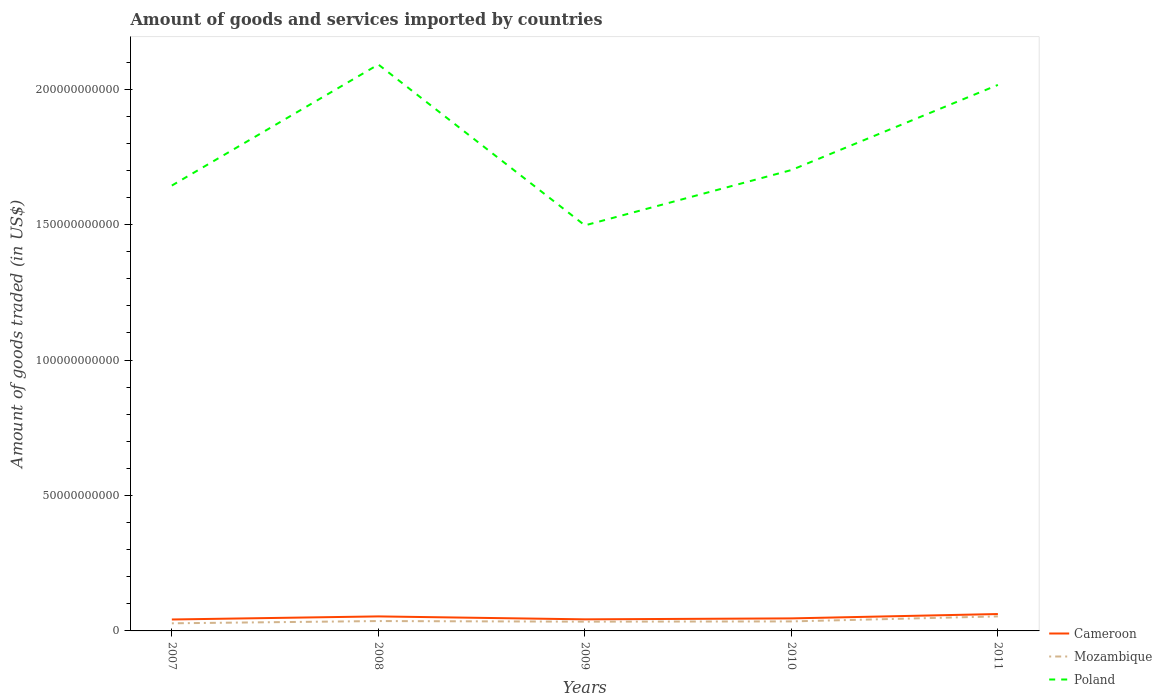How many different coloured lines are there?
Make the answer very short. 3. Does the line corresponding to Poland intersect with the line corresponding to Mozambique?
Give a very brief answer. No. Is the number of lines equal to the number of legend labels?
Ensure brevity in your answer.  Yes. Across all years, what is the maximum total amount of goods and services imported in Mozambique?
Your response must be concise. 2.81e+09. What is the total total amount of goods and services imported in Cameroon in the graph?
Make the answer very short. -5.08e+07. What is the difference between the highest and the second highest total amount of goods and services imported in Poland?
Provide a succinct answer. 5.94e+1. What is the difference between the highest and the lowest total amount of goods and services imported in Poland?
Keep it short and to the point. 2. Is the total amount of goods and services imported in Poland strictly greater than the total amount of goods and services imported in Cameroon over the years?
Provide a short and direct response. No. How many years are there in the graph?
Provide a succinct answer. 5. Are the values on the major ticks of Y-axis written in scientific E-notation?
Keep it short and to the point. No. Does the graph contain grids?
Offer a very short reply. No. Where does the legend appear in the graph?
Offer a terse response. Bottom right. How many legend labels are there?
Provide a succinct answer. 3. How are the legend labels stacked?
Provide a succinct answer. Vertical. What is the title of the graph?
Offer a terse response. Amount of goods and services imported by countries. What is the label or title of the X-axis?
Your answer should be very brief. Years. What is the label or title of the Y-axis?
Your response must be concise. Amount of goods traded (in US$). What is the Amount of goods traded (in US$) in Cameroon in 2007?
Ensure brevity in your answer.  4.22e+09. What is the Amount of goods traded (in US$) of Mozambique in 2007?
Ensure brevity in your answer.  2.81e+09. What is the Amount of goods traded (in US$) in Poland in 2007?
Give a very brief answer. 1.64e+11. What is the Amount of goods traded (in US$) in Cameroon in 2008?
Make the answer very short. 5.36e+09. What is the Amount of goods traded (in US$) in Mozambique in 2008?
Provide a short and direct response. 3.64e+09. What is the Amount of goods traded (in US$) of Poland in 2008?
Your answer should be compact. 2.09e+11. What is the Amount of goods traded (in US$) of Cameroon in 2009?
Your answer should be very brief. 4.27e+09. What is the Amount of goods traded (in US$) in Mozambique in 2009?
Give a very brief answer. 3.42e+09. What is the Amount of goods traded (in US$) of Poland in 2009?
Offer a very short reply. 1.50e+11. What is the Amount of goods traded (in US$) in Cameroon in 2010?
Your answer should be compact. 4.63e+09. What is the Amount of goods traded (in US$) of Mozambique in 2010?
Make the answer very short. 3.51e+09. What is the Amount of goods traded (in US$) of Poland in 2010?
Provide a succinct answer. 1.70e+11. What is the Amount of goods traded (in US$) in Cameroon in 2011?
Give a very brief answer. 6.23e+09. What is the Amount of goods traded (in US$) in Mozambique in 2011?
Your response must be concise. 5.37e+09. What is the Amount of goods traded (in US$) in Poland in 2011?
Give a very brief answer. 2.02e+11. Across all years, what is the maximum Amount of goods traded (in US$) of Cameroon?
Keep it short and to the point. 6.23e+09. Across all years, what is the maximum Amount of goods traded (in US$) in Mozambique?
Your answer should be compact. 5.37e+09. Across all years, what is the maximum Amount of goods traded (in US$) in Poland?
Provide a short and direct response. 2.09e+11. Across all years, what is the minimum Amount of goods traded (in US$) of Cameroon?
Offer a terse response. 4.22e+09. Across all years, what is the minimum Amount of goods traded (in US$) in Mozambique?
Your answer should be compact. 2.81e+09. Across all years, what is the minimum Amount of goods traded (in US$) in Poland?
Give a very brief answer. 1.50e+11. What is the total Amount of goods traded (in US$) of Cameroon in the graph?
Your answer should be very brief. 2.47e+1. What is the total Amount of goods traded (in US$) of Mozambique in the graph?
Make the answer very short. 1.88e+1. What is the total Amount of goods traded (in US$) in Poland in the graph?
Give a very brief answer. 8.95e+11. What is the difference between the Amount of goods traded (in US$) of Cameroon in 2007 and that in 2008?
Make the answer very short. -1.14e+09. What is the difference between the Amount of goods traded (in US$) of Mozambique in 2007 and that in 2008?
Offer a terse response. -8.32e+08. What is the difference between the Amount of goods traded (in US$) in Poland in 2007 and that in 2008?
Give a very brief answer. -4.47e+1. What is the difference between the Amount of goods traded (in US$) of Cameroon in 2007 and that in 2009?
Your response must be concise. -5.08e+07. What is the difference between the Amount of goods traded (in US$) of Mozambique in 2007 and that in 2009?
Keep it short and to the point. -6.11e+08. What is the difference between the Amount of goods traded (in US$) in Poland in 2007 and that in 2009?
Your answer should be compact. 1.47e+1. What is the difference between the Amount of goods traded (in US$) in Cameroon in 2007 and that in 2010?
Give a very brief answer. -4.05e+08. What is the difference between the Amount of goods traded (in US$) of Mozambique in 2007 and that in 2010?
Keep it short and to the point. -7.01e+08. What is the difference between the Amount of goods traded (in US$) in Poland in 2007 and that in 2010?
Your answer should be compact. -5.72e+09. What is the difference between the Amount of goods traded (in US$) of Cameroon in 2007 and that in 2011?
Offer a very short reply. -2.01e+09. What is the difference between the Amount of goods traded (in US$) in Mozambique in 2007 and that in 2011?
Offer a very short reply. -2.56e+09. What is the difference between the Amount of goods traded (in US$) of Poland in 2007 and that in 2011?
Make the answer very short. -3.71e+1. What is the difference between the Amount of goods traded (in US$) of Cameroon in 2008 and that in 2009?
Keep it short and to the point. 1.09e+09. What is the difference between the Amount of goods traded (in US$) of Mozambique in 2008 and that in 2009?
Provide a short and direct response. 2.21e+08. What is the difference between the Amount of goods traded (in US$) in Poland in 2008 and that in 2009?
Your answer should be very brief. 5.94e+1. What is the difference between the Amount of goods traded (in US$) of Cameroon in 2008 and that in 2010?
Your answer should be very brief. 7.32e+08. What is the difference between the Amount of goods traded (in US$) of Mozambique in 2008 and that in 2010?
Your answer should be compact. 1.31e+08. What is the difference between the Amount of goods traded (in US$) of Poland in 2008 and that in 2010?
Offer a terse response. 3.90e+1. What is the difference between the Amount of goods traded (in US$) of Cameroon in 2008 and that in 2011?
Offer a very short reply. -8.75e+08. What is the difference between the Amount of goods traded (in US$) in Mozambique in 2008 and that in 2011?
Provide a short and direct response. -1.72e+09. What is the difference between the Amount of goods traded (in US$) of Poland in 2008 and that in 2011?
Ensure brevity in your answer.  7.54e+09. What is the difference between the Amount of goods traded (in US$) of Cameroon in 2009 and that in 2010?
Offer a terse response. -3.54e+08. What is the difference between the Amount of goods traded (in US$) of Mozambique in 2009 and that in 2010?
Ensure brevity in your answer.  -9.04e+07. What is the difference between the Amount of goods traded (in US$) of Poland in 2009 and that in 2010?
Offer a very short reply. -2.04e+1. What is the difference between the Amount of goods traded (in US$) in Cameroon in 2009 and that in 2011?
Provide a succinct answer. -1.96e+09. What is the difference between the Amount of goods traded (in US$) of Mozambique in 2009 and that in 2011?
Give a very brief answer. -1.95e+09. What is the difference between the Amount of goods traded (in US$) in Poland in 2009 and that in 2011?
Provide a succinct answer. -5.18e+1. What is the difference between the Amount of goods traded (in US$) in Cameroon in 2010 and that in 2011?
Your response must be concise. -1.61e+09. What is the difference between the Amount of goods traded (in US$) in Mozambique in 2010 and that in 2011?
Your answer should be compact. -1.86e+09. What is the difference between the Amount of goods traded (in US$) in Poland in 2010 and that in 2011?
Make the answer very short. -3.14e+1. What is the difference between the Amount of goods traded (in US$) in Cameroon in 2007 and the Amount of goods traded (in US$) in Mozambique in 2008?
Make the answer very short. 5.78e+08. What is the difference between the Amount of goods traded (in US$) in Cameroon in 2007 and the Amount of goods traded (in US$) in Poland in 2008?
Ensure brevity in your answer.  -2.05e+11. What is the difference between the Amount of goods traded (in US$) of Mozambique in 2007 and the Amount of goods traded (in US$) of Poland in 2008?
Provide a succinct answer. -2.06e+11. What is the difference between the Amount of goods traded (in US$) of Cameroon in 2007 and the Amount of goods traded (in US$) of Mozambique in 2009?
Your answer should be very brief. 7.99e+08. What is the difference between the Amount of goods traded (in US$) of Cameroon in 2007 and the Amount of goods traded (in US$) of Poland in 2009?
Your answer should be compact. -1.45e+11. What is the difference between the Amount of goods traded (in US$) in Mozambique in 2007 and the Amount of goods traded (in US$) in Poland in 2009?
Ensure brevity in your answer.  -1.47e+11. What is the difference between the Amount of goods traded (in US$) in Cameroon in 2007 and the Amount of goods traded (in US$) in Mozambique in 2010?
Keep it short and to the point. 7.09e+08. What is the difference between the Amount of goods traded (in US$) of Cameroon in 2007 and the Amount of goods traded (in US$) of Poland in 2010?
Keep it short and to the point. -1.66e+11. What is the difference between the Amount of goods traded (in US$) in Mozambique in 2007 and the Amount of goods traded (in US$) in Poland in 2010?
Provide a short and direct response. -1.67e+11. What is the difference between the Amount of goods traded (in US$) of Cameroon in 2007 and the Amount of goods traded (in US$) of Mozambique in 2011?
Keep it short and to the point. -1.15e+09. What is the difference between the Amount of goods traded (in US$) of Cameroon in 2007 and the Amount of goods traded (in US$) of Poland in 2011?
Your response must be concise. -1.97e+11. What is the difference between the Amount of goods traded (in US$) of Mozambique in 2007 and the Amount of goods traded (in US$) of Poland in 2011?
Offer a terse response. -1.99e+11. What is the difference between the Amount of goods traded (in US$) in Cameroon in 2008 and the Amount of goods traded (in US$) in Mozambique in 2009?
Keep it short and to the point. 1.94e+09. What is the difference between the Amount of goods traded (in US$) of Cameroon in 2008 and the Amount of goods traded (in US$) of Poland in 2009?
Offer a terse response. -1.44e+11. What is the difference between the Amount of goods traded (in US$) in Mozambique in 2008 and the Amount of goods traded (in US$) in Poland in 2009?
Ensure brevity in your answer.  -1.46e+11. What is the difference between the Amount of goods traded (in US$) in Cameroon in 2008 and the Amount of goods traded (in US$) in Mozambique in 2010?
Offer a very short reply. 1.85e+09. What is the difference between the Amount of goods traded (in US$) of Cameroon in 2008 and the Amount of goods traded (in US$) of Poland in 2010?
Make the answer very short. -1.65e+11. What is the difference between the Amount of goods traded (in US$) of Mozambique in 2008 and the Amount of goods traded (in US$) of Poland in 2010?
Ensure brevity in your answer.  -1.66e+11. What is the difference between the Amount of goods traded (in US$) of Cameroon in 2008 and the Amount of goods traded (in US$) of Mozambique in 2011?
Offer a very short reply. -9.71e+06. What is the difference between the Amount of goods traded (in US$) of Cameroon in 2008 and the Amount of goods traded (in US$) of Poland in 2011?
Keep it short and to the point. -1.96e+11. What is the difference between the Amount of goods traded (in US$) of Mozambique in 2008 and the Amount of goods traded (in US$) of Poland in 2011?
Provide a succinct answer. -1.98e+11. What is the difference between the Amount of goods traded (in US$) in Cameroon in 2009 and the Amount of goods traded (in US$) in Mozambique in 2010?
Provide a succinct answer. 7.60e+08. What is the difference between the Amount of goods traded (in US$) in Cameroon in 2009 and the Amount of goods traded (in US$) in Poland in 2010?
Offer a very short reply. -1.66e+11. What is the difference between the Amount of goods traded (in US$) in Mozambique in 2009 and the Amount of goods traded (in US$) in Poland in 2010?
Offer a terse response. -1.67e+11. What is the difference between the Amount of goods traded (in US$) in Cameroon in 2009 and the Amount of goods traded (in US$) in Mozambique in 2011?
Keep it short and to the point. -1.10e+09. What is the difference between the Amount of goods traded (in US$) of Cameroon in 2009 and the Amount of goods traded (in US$) of Poland in 2011?
Your response must be concise. -1.97e+11. What is the difference between the Amount of goods traded (in US$) in Mozambique in 2009 and the Amount of goods traded (in US$) in Poland in 2011?
Offer a very short reply. -1.98e+11. What is the difference between the Amount of goods traded (in US$) in Cameroon in 2010 and the Amount of goods traded (in US$) in Mozambique in 2011?
Your answer should be compact. -7.42e+08. What is the difference between the Amount of goods traded (in US$) in Cameroon in 2010 and the Amount of goods traded (in US$) in Poland in 2011?
Offer a terse response. -1.97e+11. What is the difference between the Amount of goods traded (in US$) in Mozambique in 2010 and the Amount of goods traded (in US$) in Poland in 2011?
Ensure brevity in your answer.  -1.98e+11. What is the average Amount of goods traded (in US$) of Cameroon per year?
Give a very brief answer. 4.94e+09. What is the average Amount of goods traded (in US$) of Mozambique per year?
Provide a short and direct response. 3.75e+09. What is the average Amount of goods traded (in US$) of Poland per year?
Your response must be concise. 1.79e+11. In the year 2007, what is the difference between the Amount of goods traded (in US$) in Cameroon and Amount of goods traded (in US$) in Mozambique?
Give a very brief answer. 1.41e+09. In the year 2007, what is the difference between the Amount of goods traded (in US$) of Cameroon and Amount of goods traded (in US$) of Poland?
Give a very brief answer. -1.60e+11. In the year 2007, what is the difference between the Amount of goods traded (in US$) of Mozambique and Amount of goods traded (in US$) of Poland?
Make the answer very short. -1.62e+11. In the year 2008, what is the difference between the Amount of goods traded (in US$) of Cameroon and Amount of goods traded (in US$) of Mozambique?
Provide a short and direct response. 1.71e+09. In the year 2008, what is the difference between the Amount of goods traded (in US$) in Cameroon and Amount of goods traded (in US$) in Poland?
Provide a succinct answer. -2.04e+11. In the year 2008, what is the difference between the Amount of goods traded (in US$) in Mozambique and Amount of goods traded (in US$) in Poland?
Offer a terse response. -2.05e+11. In the year 2009, what is the difference between the Amount of goods traded (in US$) of Cameroon and Amount of goods traded (in US$) of Mozambique?
Give a very brief answer. 8.50e+08. In the year 2009, what is the difference between the Amount of goods traded (in US$) of Cameroon and Amount of goods traded (in US$) of Poland?
Provide a succinct answer. -1.45e+11. In the year 2009, what is the difference between the Amount of goods traded (in US$) of Mozambique and Amount of goods traded (in US$) of Poland?
Give a very brief answer. -1.46e+11. In the year 2010, what is the difference between the Amount of goods traded (in US$) of Cameroon and Amount of goods traded (in US$) of Mozambique?
Make the answer very short. 1.11e+09. In the year 2010, what is the difference between the Amount of goods traded (in US$) in Cameroon and Amount of goods traded (in US$) in Poland?
Give a very brief answer. -1.66e+11. In the year 2010, what is the difference between the Amount of goods traded (in US$) in Mozambique and Amount of goods traded (in US$) in Poland?
Provide a succinct answer. -1.67e+11. In the year 2011, what is the difference between the Amount of goods traded (in US$) in Cameroon and Amount of goods traded (in US$) in Mozambique?
Make the answer very short. 8.65e+08. In the year 2011, what is the difference between the Amount of goods traded (in US$) in Cameroon and Amount of goods traded (in US$) in Poland?
Provide a succinct answer. -1.95e+11. In the year 2011, what is the difference between the Amount of goods traded (in US$) in Mozambique and Amount of goods traded (in US$) in Poland?
Your answer should be very brief. -1.96e+11. What is the ratio of the Amount of goods traded (in US$) of Cameroon in 2007 to that in 2008?
Ensure brevity in your answer.  0.79. What is the ratio of the Amount of goods traded (in US$) of Mozambique in 2007 to that in 2008?
Your answer should be compact. 0.77. What is the ratio of the Amount of goods traded (in US$) in Poland in 2007 to that in 2008?
Provide a succinct answer. 0.79. What is the ratio of the Amount of goods traded (in US$) of Cameroon in 2007 to that in 2009?
Make the answer very short. 0.99. What is the ratio of the Amount of goods traded (in US$) in Mozambique in 2007 to that in 2009?
Offer a terse response. 0.82. What is the ratio of the Amount of goods traded (in US$) of Poland in 2007 to that in 2009?
Keep it short and to the point. 1.1. What is the ratio of the Amount of goods traded (in US$) in Cameroon in 2007 to that in 2010?
Give a very brief answer. 0.91. What is the ratio of the Amount of goods traded (in US$) of Mozambique in 2007 to that in 2010?
Offer a very short reply. 0.8. What is the ratio of the Amount of goods traded (in US$) of Poland in 2007 to that in 2010?
Offer a very short reply. 0.97. What is the ratio of the Amount of goods traded (in US$) in Cameroon in 2007 to that in 2011?
Ensure brevity in your answer.  0.68. What is the ratio of the Amount of goods traded (in US$) of Mozambique in 2007 to that in 2011?
Your answer should be very brief. 0.52. What is the ratio of the Amount of goods traded (in US$) of Poland in 2007 to that in 2011?
Offer a terse response. 0.82. What is the ratio of the Amount of goods traded (in US$) of Cameroon in 2008 to that in 2009?
Ensure brevity in your answer.  1.25. What is the ratio of the Amount of goods traded (in US$) of Mozambique in 2008 to that in 2009?
Your answer should be very brief. 1.06. What is the ratio of the Amount of goods traded (in US$) of Poland in 2008 to that in 2009?
Your response must be concise. 1.4. What is the ratio of the Amount of goods traded (in US$) in Cameroon in 2008 to that in 2010?
Keep it short and to the point. 1.16. What is the ratio of the Amount of goods traded (in US$) of Mozambique in 2008 to that in 2010?
Your answer should be compact. 1.04. What is the ratio of the Amount of goods traded (in US$) of Poland in 2008 to that in 2010?
Your response must be concise. 1.23. What is the ratio of the Amount of goods traded (in US$) of Cameroon in 2008 to that in 2011?
Ensure brevity in your answer.  0.86. What is the ratio of the Amount of goods traded (in US$) in Mozambique in 2008 to that in 2011?
Your answer should be very brief. 0.68. What is the ratio of the Amount of goods traded (in US$) of Poland in 2008 to that in 2011?
Make the answer very short. 1.04. What is the ratio of the Amount of goods traded (in US$) in Cameroon in 2009 to that in 2010?
Give a very brief answer. 0.92. What is the ratio of the Amount of goods traded (in US$) in Mozambique in 2009 to that in 2010?
Make the answer very short. 0.97. What is the ratio of the Amount of goods traded (in US$) of Poland in 2009 to that in 2010?
Provide a short and direct response. 0.88. What is the ratio of the Amount of goods traded (in US$) of Cameroon in 2009 to that in 2011?
Ensure brevity in your answer.  0.69. What is the ratio of the Amount of goods traded (in US$) of Mozambique in 2009 to that in 2011?
Offer a terse response. 0.64. What is the ratio of the Amount of goods traded (in US$) of Poland in 2009 to that in 2011?
Offer a terse response. 0.74. What is the ratio of the Amount of goods traded (in US$) of Cameroon in 2010 to that in 2011?
Provide a short and direct response. 0.74. What is the ratio of the Amount of goods traded (in US$) of Mozambique in 2010 to that in 2011?
Provide a short and direct response. 0.65. What is the ratio of the Amount of goods traded (in US$) in Poland in 2010 to that in 2011?
Make the answer very short. 0.84. What is the difference between the highest and the second highest Amount of goods traded (in US$) in Cameroon?
Ensure brevity in your answer.  8.75e+08. What is the difference between the highest and the second highest Amount of goods traded (in US$) of Mozambique?
Provide a short and direct response. 1.72e+09. What is the difference between the highest and the second highest Amount of goods traded (in US$) in Poland?
Your answer should be very brief. 7.54e+09. What is the difference between the highest and the lowest Amount of goods traded (in US$) of Cameroon?
Provide a short and direct response. 2.01e+09. What is the difference between the highest and the lowest Amount of goods traded (in US$) in Mozambique?
Provide a short and direct response. 2.56e+09. What is the difference between the highest and the lowest Amount of goods traded (in US$) in Poland?
Provide a short and direct response. 5.94e+1. 